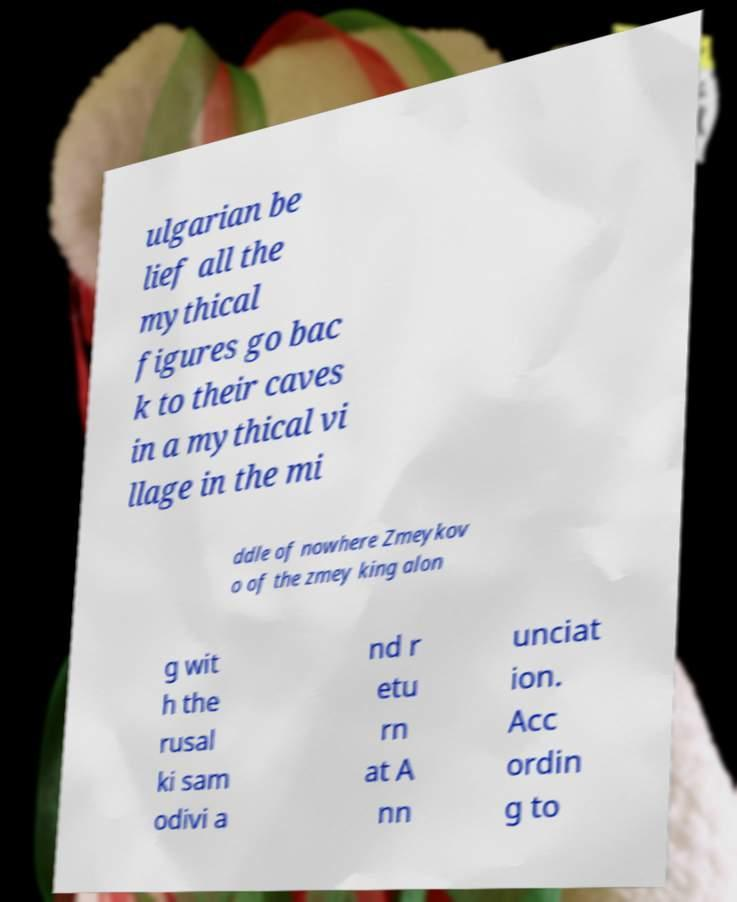I need the written content from this picture converted into text. Can you do that? ulgarian be lief all the mythical figures go bac k to their caves in a mythical vi llage in the mi ddle of nowhere Zmeykov o of the zmey king alon g wit h the rusal ki sam odivi a nd r etu rn at A nn unciat ion. Acc ordin g to 